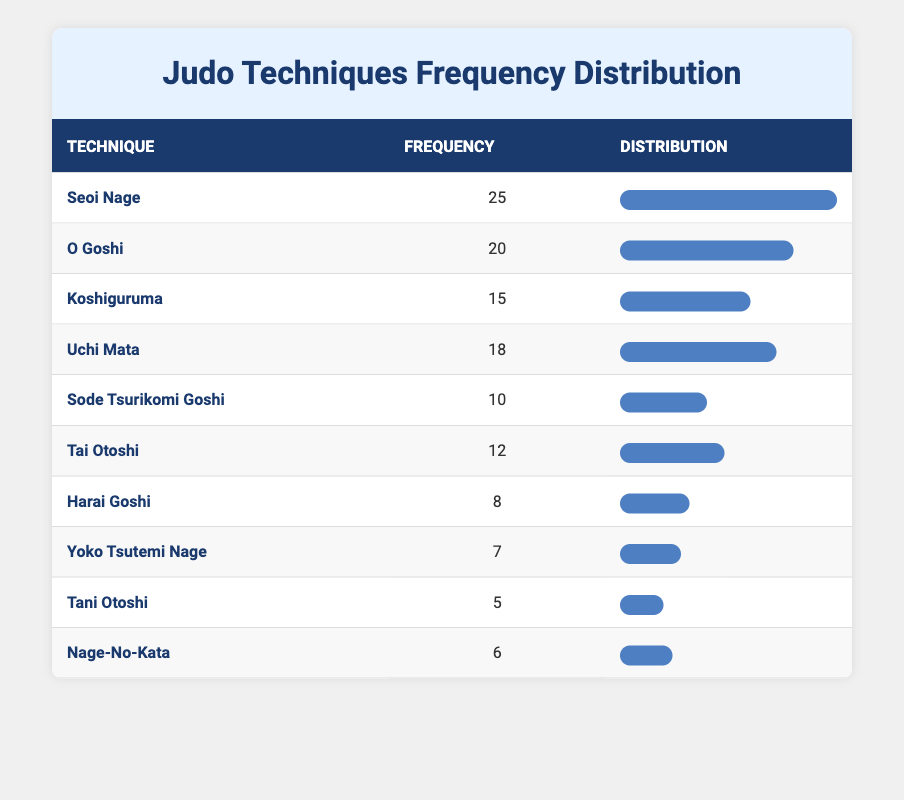What is the most frequently used judo technique in matches? The technique with the highest frequency in the table is Seoi Nage, which has a frequency of 25.
Answer: Seoi Nage How many times was Uchi Mata used compared to Tai Otoshi? Uchi Mata was used 18 times, while Tai Otoshi was used 12 times. The difference is 18 - 12 = 6.
Answer: 6 Is the frequency of Sode Tsurikomi Goshi greater than Tai Otoshi? Sode Tsurikomi Goshi has a frequency of 10, while Tai Otoshi has a frequency of 12. Since 10 is less than 12, the statement is false.
Answer: No What is the average frequency of the listed judo techniques? The total frequency of all techniques is (25 + 20 + 15 + 18 + 10 + 12 + 8 + 7 + 5 + 6) = 126. There are 10 techniques, so the average is 126/10 = 12.6.
Answer: 12.6 Which techniques have a frequency greater than 15? The techniques with a frequency greater than 15 are Seoi Nage (25), O Goshi (20), and Uchi Mata (18).
Answer: Seoi Nage, O Goshi, Uchi Mata What is the total frequency of the least used techniques? The least used techniques are Tani Otoshi (5) and Yoko Tsutemi Nage (7). Their total frequency is 5 + 7 = 12.
Answer: 12 Which technique has the lowest frequency? Among all the techniques listed, Tani Otoshi has the lowest frequency at 5.
Answer: Tani Otoshi Is the frequency of Harai Goshi equal to the sum of the frequencies of Nage-No-Kata and Yoko Tsutemi Nage? Harai Goshi has a frequency of 8, while Nage-No-Kata has a frequency of 6 and Yoko Tsutemi Nage has a frequency of 7. The sum is 6 + 7 = 13, which is greater than 8. Therefore, the statement is false.
Answer: No 